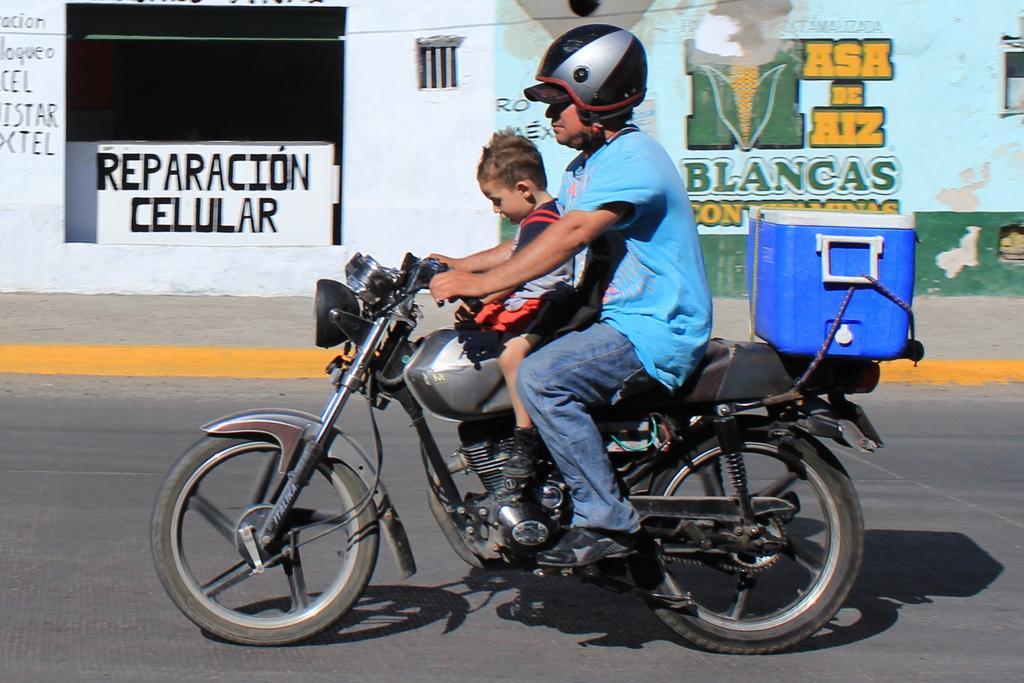In one or two sentences, can you explain what this image depicts? This picture shows a man and a boy moving on a motor cycle on the road and we see a box tied to the vehicle. 